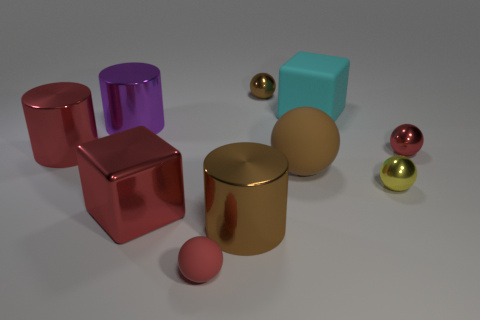Subtract all yellow spheres. How many spheres are left? 4 Subtract all yellow metallic balls. How many balls are left? 4 Subtract all gray balls. Subtract all red cylinders. How many balls are left? 5 Subtract all blocks. How many objects are left? 8 Subtract all small green blocks. Subtract all tiny red rubber things. How many objects are left? 9 Add 7 large metal cylinders. How many large metal cylinders are left? 10 Add 7 big cyan things. How many big cyan things exist? 8 Subtract 0 green balls. How many objects are left? 10 